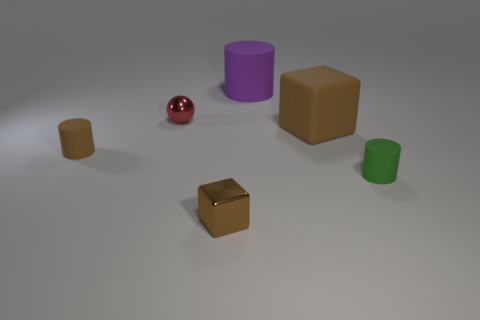Add 3 purple metal balls. How many objects exist? 9 Subtract all blocks. How many objects are left? 4 Add 2 green rubber cylinders. How many green rubber cylinders exist? 3 Subtract 1 green cylinders. How many objects are left? 5 Subtract all large cylinders. Subtract all small brown metallic objects. How many objects are left? 4 Add 4 small metal objects. How many small metal objects are left? 6 